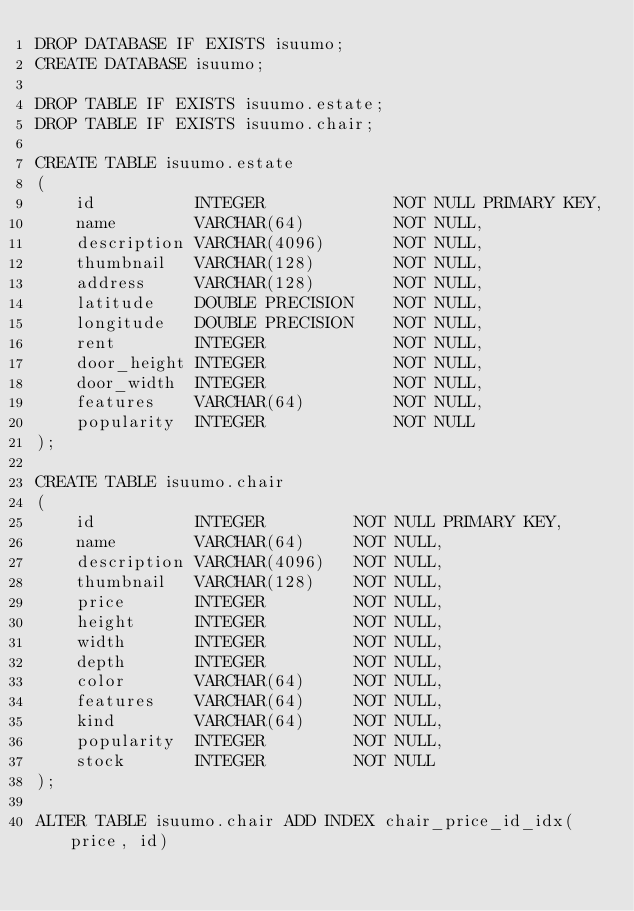<code> <loc_0><loc_0><loc_500><loc_500><_SQL_>DROP DATABASE IF EXISTS isuumo;
CREATE DATABASE isuumo;

DROP TABLE IF EXISTS isuumo.estate;
DROP TABLE IF EXISTS isuumo.chair;

CREATE TABLE isuumo.estate
(
    id          INTEGER             NOT NULL PRIMARY KEY,
    name        VARCHAR(64)         NOT NULL,
    description VARCHAR(4096)       NOT NULL,
    thumbnail   VARCHAR(128)        NOT NULL,
    address     VARCHAR(128)        NOT NULL,
    latitude    DOUBLE PRECISION    NOT NULL,
    longitude   DOUBLE PRECISION    NOT NULL,
    rent        INTEGER             NOT NULL,
    door_height INTEGER             NOT NULL,
    door_width  INTEGER             NOT NULL,
    features    VARCHAR(64)         NOT NULL,
    popularity  INTEGER             NOT NULL
);

CREATE TABLE isuumo.chair
(
    id          INTEGER         NOT NULL PRIMARY KEY,
    name        VARCHAR(64)     NOT NULL,
    description VARCHAR(4096)   NOT NULL,
    thumbnail   VARCHAR(128)    NOT NULL,
    price       INTEGER         NOT NULL,
    height      INTEGER         NOT NULL,
    width       INTEGER         NOT NULL,
    depth       INTEGER         NOT NULL,
    color       VARCHAR(64)     NOT NULL,
    features    VARCHAR(64)     NOT NULL,
    kind        VARCHAR(64)     NOT NULL,
    popularity  INTEGER         NOT NULL,
    stock       INTEGER         NOT NULL
);

ALTER TABLE isuumo.chair ADD INDEX chair_price_id_idx(price, id)
</code> 